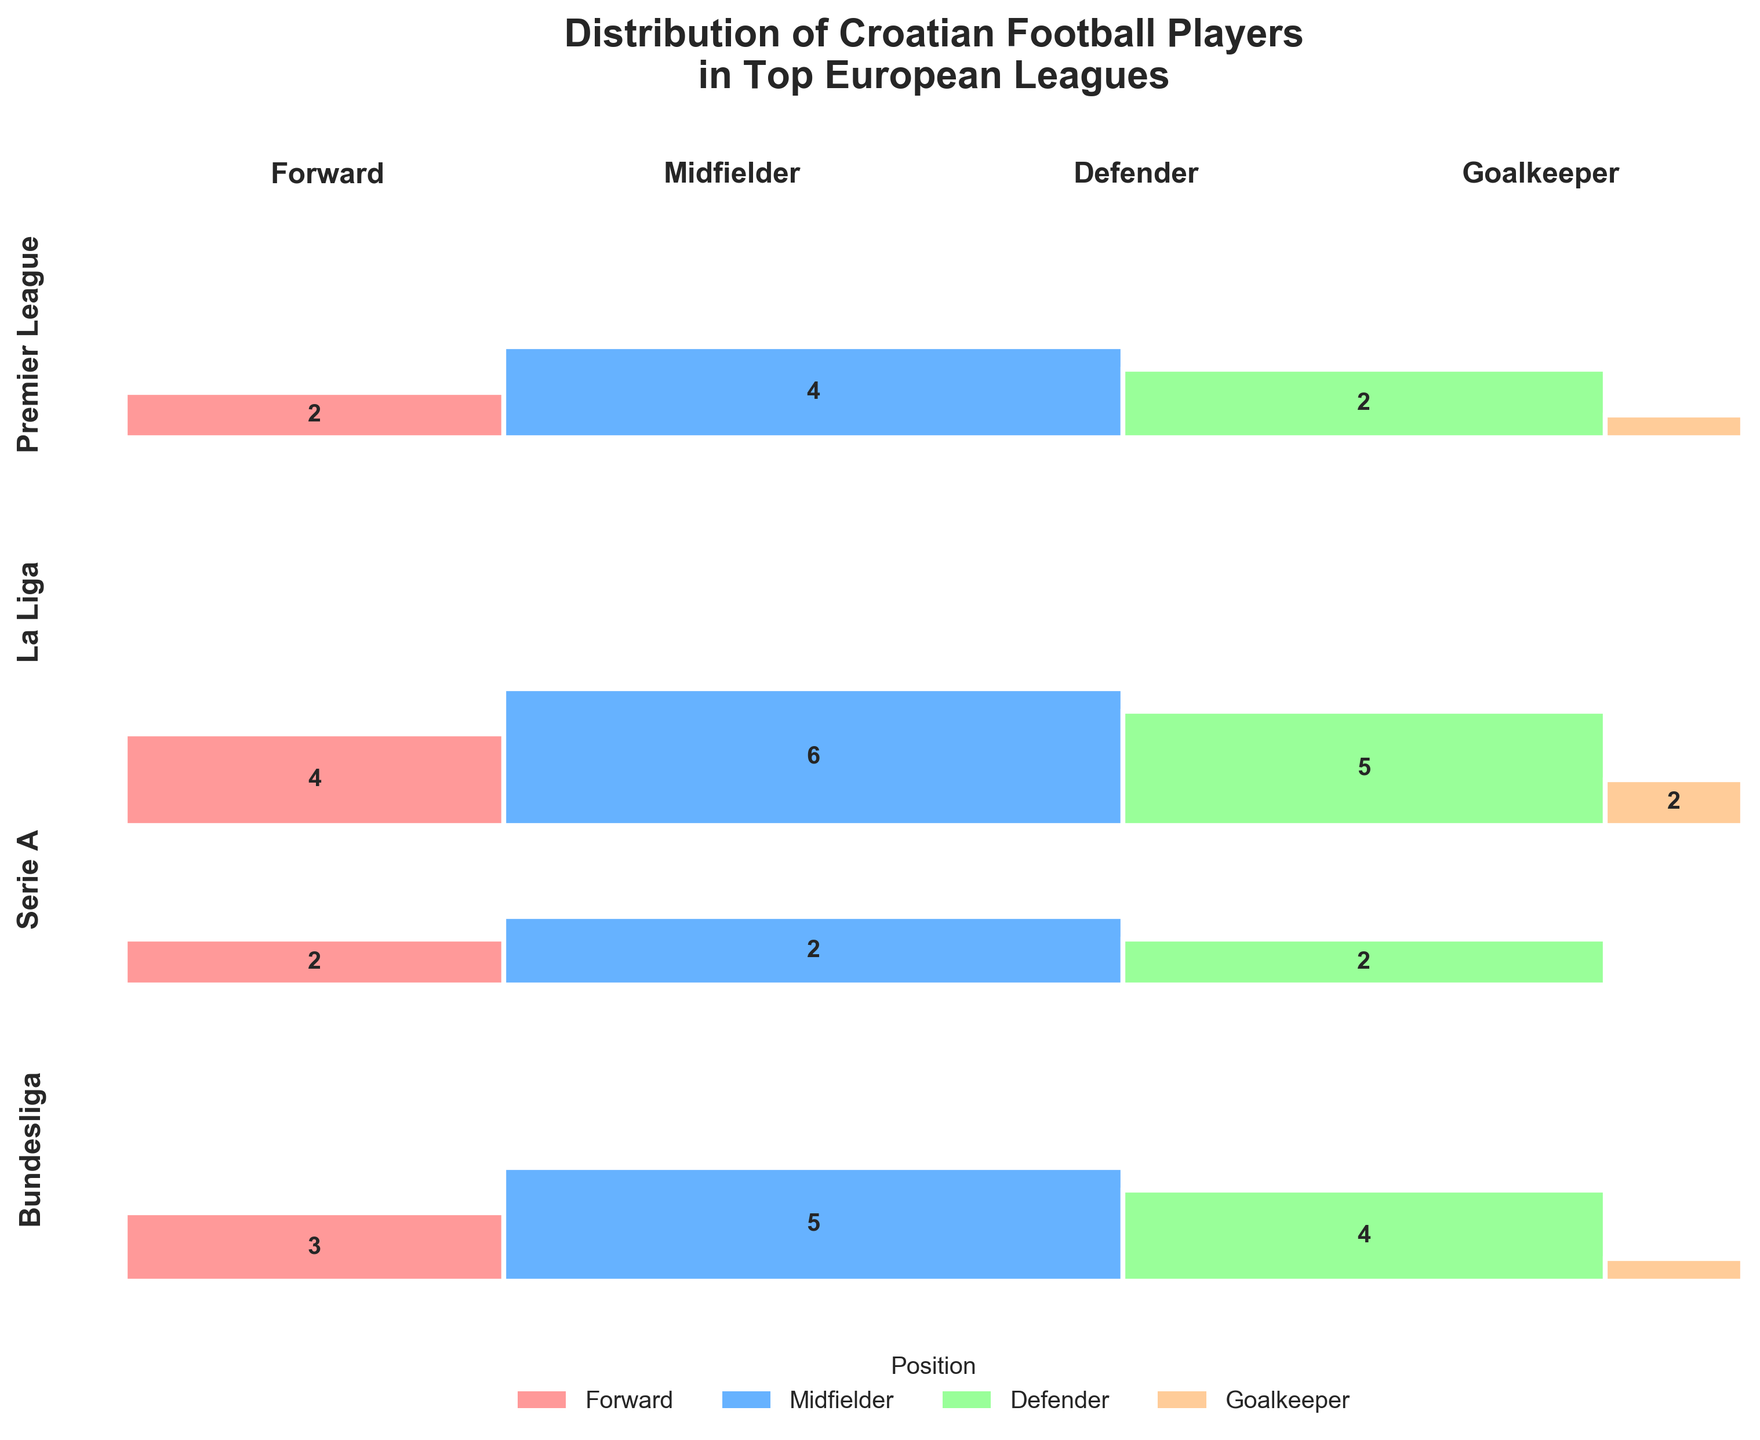Which league has the highest number of Croatian midfielders? Look at the height of the Midfielder section for each league and find that Serie A has the tallest rectangle for Midfielders.
Answer: Serie A Which position has the fewest Croatian players in La Liga? Compare the heights of the four sections (Forward, Midfielder, Defender, Goalkeeper) within La Liga and notice that the Goalkeeper section has the smallest height.
Answer: Goalkeeper How many Croatian forwards are there in the Premier League? Look at the number inside the rectangle corresponding to Forwards in the Premier League.
Answer: 3 Which league has the most balanced distribution of Croatian football players across different positions? Compare the tallness of the rectangles within each league and see which league has similar heights for all positions. Serie A has the most balanced distribution as the heights of the four sections are quite similar.
Answer: Serie A Are there more Croatian defenders in Serie A or Bundesliga? Compare the height of the Defender section in Serie A against the Defender section in Bundesliga. Serie A has a taller rectangle in the Defender section.
Answer: Serie A How many Croatian players are there in total in Bundesliga? Add the numbers inside the four sections (Forward, Midfielder, Defender, Goalkeeper) within the Bundesliga section.
Answer: 10 Which position has the largest rectangle overall? Check the combined width and height of each position across all leagues. Midfielders have the largest combined area.
Answer: Midfielder Which league has the highest total number of Croatian players? Compare the overall heights of the sections corresponding to each league. Serie A has the highest overall height.
Answer: Serie A How many Croatian players are there in total in Serie A? Add the numbers inside the four sections (Forward, Midfielder, Defender, Goalkeeper) within the Serie A section.
Answer: 17 